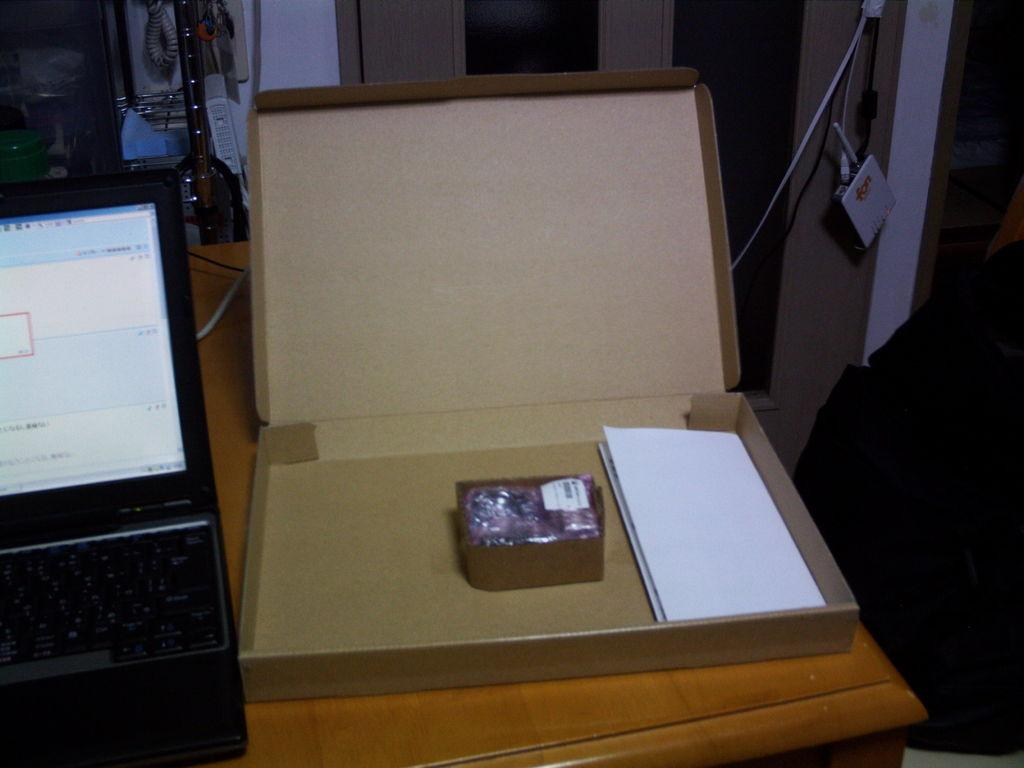What electronic device is visible in the image? There is a laptop in the image. What other objects are on the table with the laptop? There is a cardboard and a paper on the table. What can be seen in the background of the image? There is a pole and a wall in the background of the image. What type of ghost can be seen in the image? There is no ghost present in the image. 